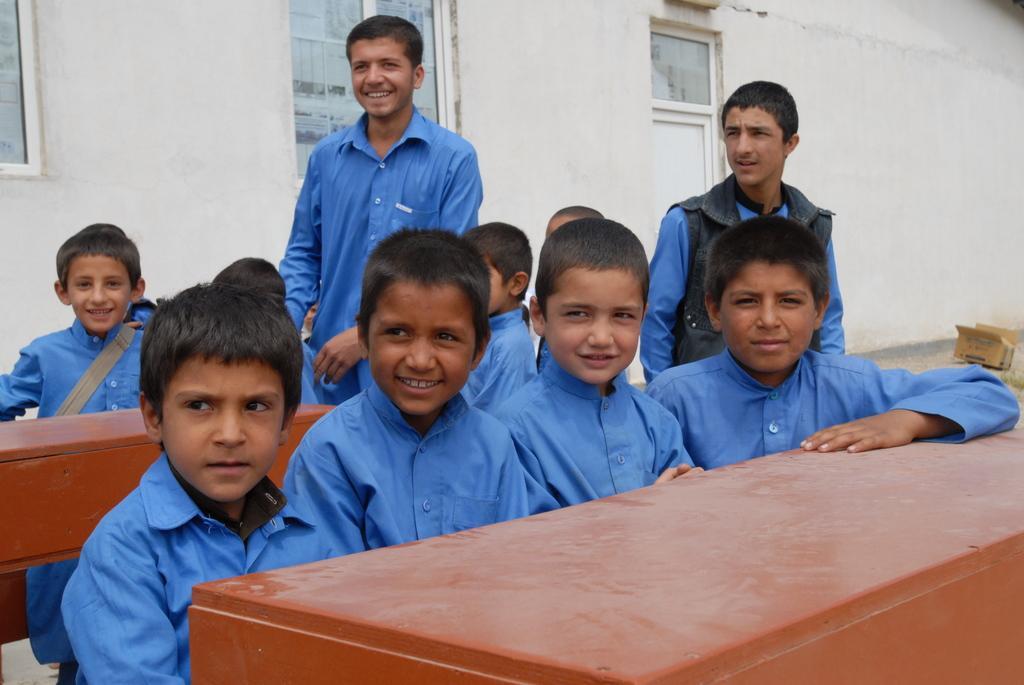Could you give a brief overview of what you see in this image? In this image we can see a group of people where some of them are sitting and standing around the tables, there we can see few windows, a door and a cardboard box. 